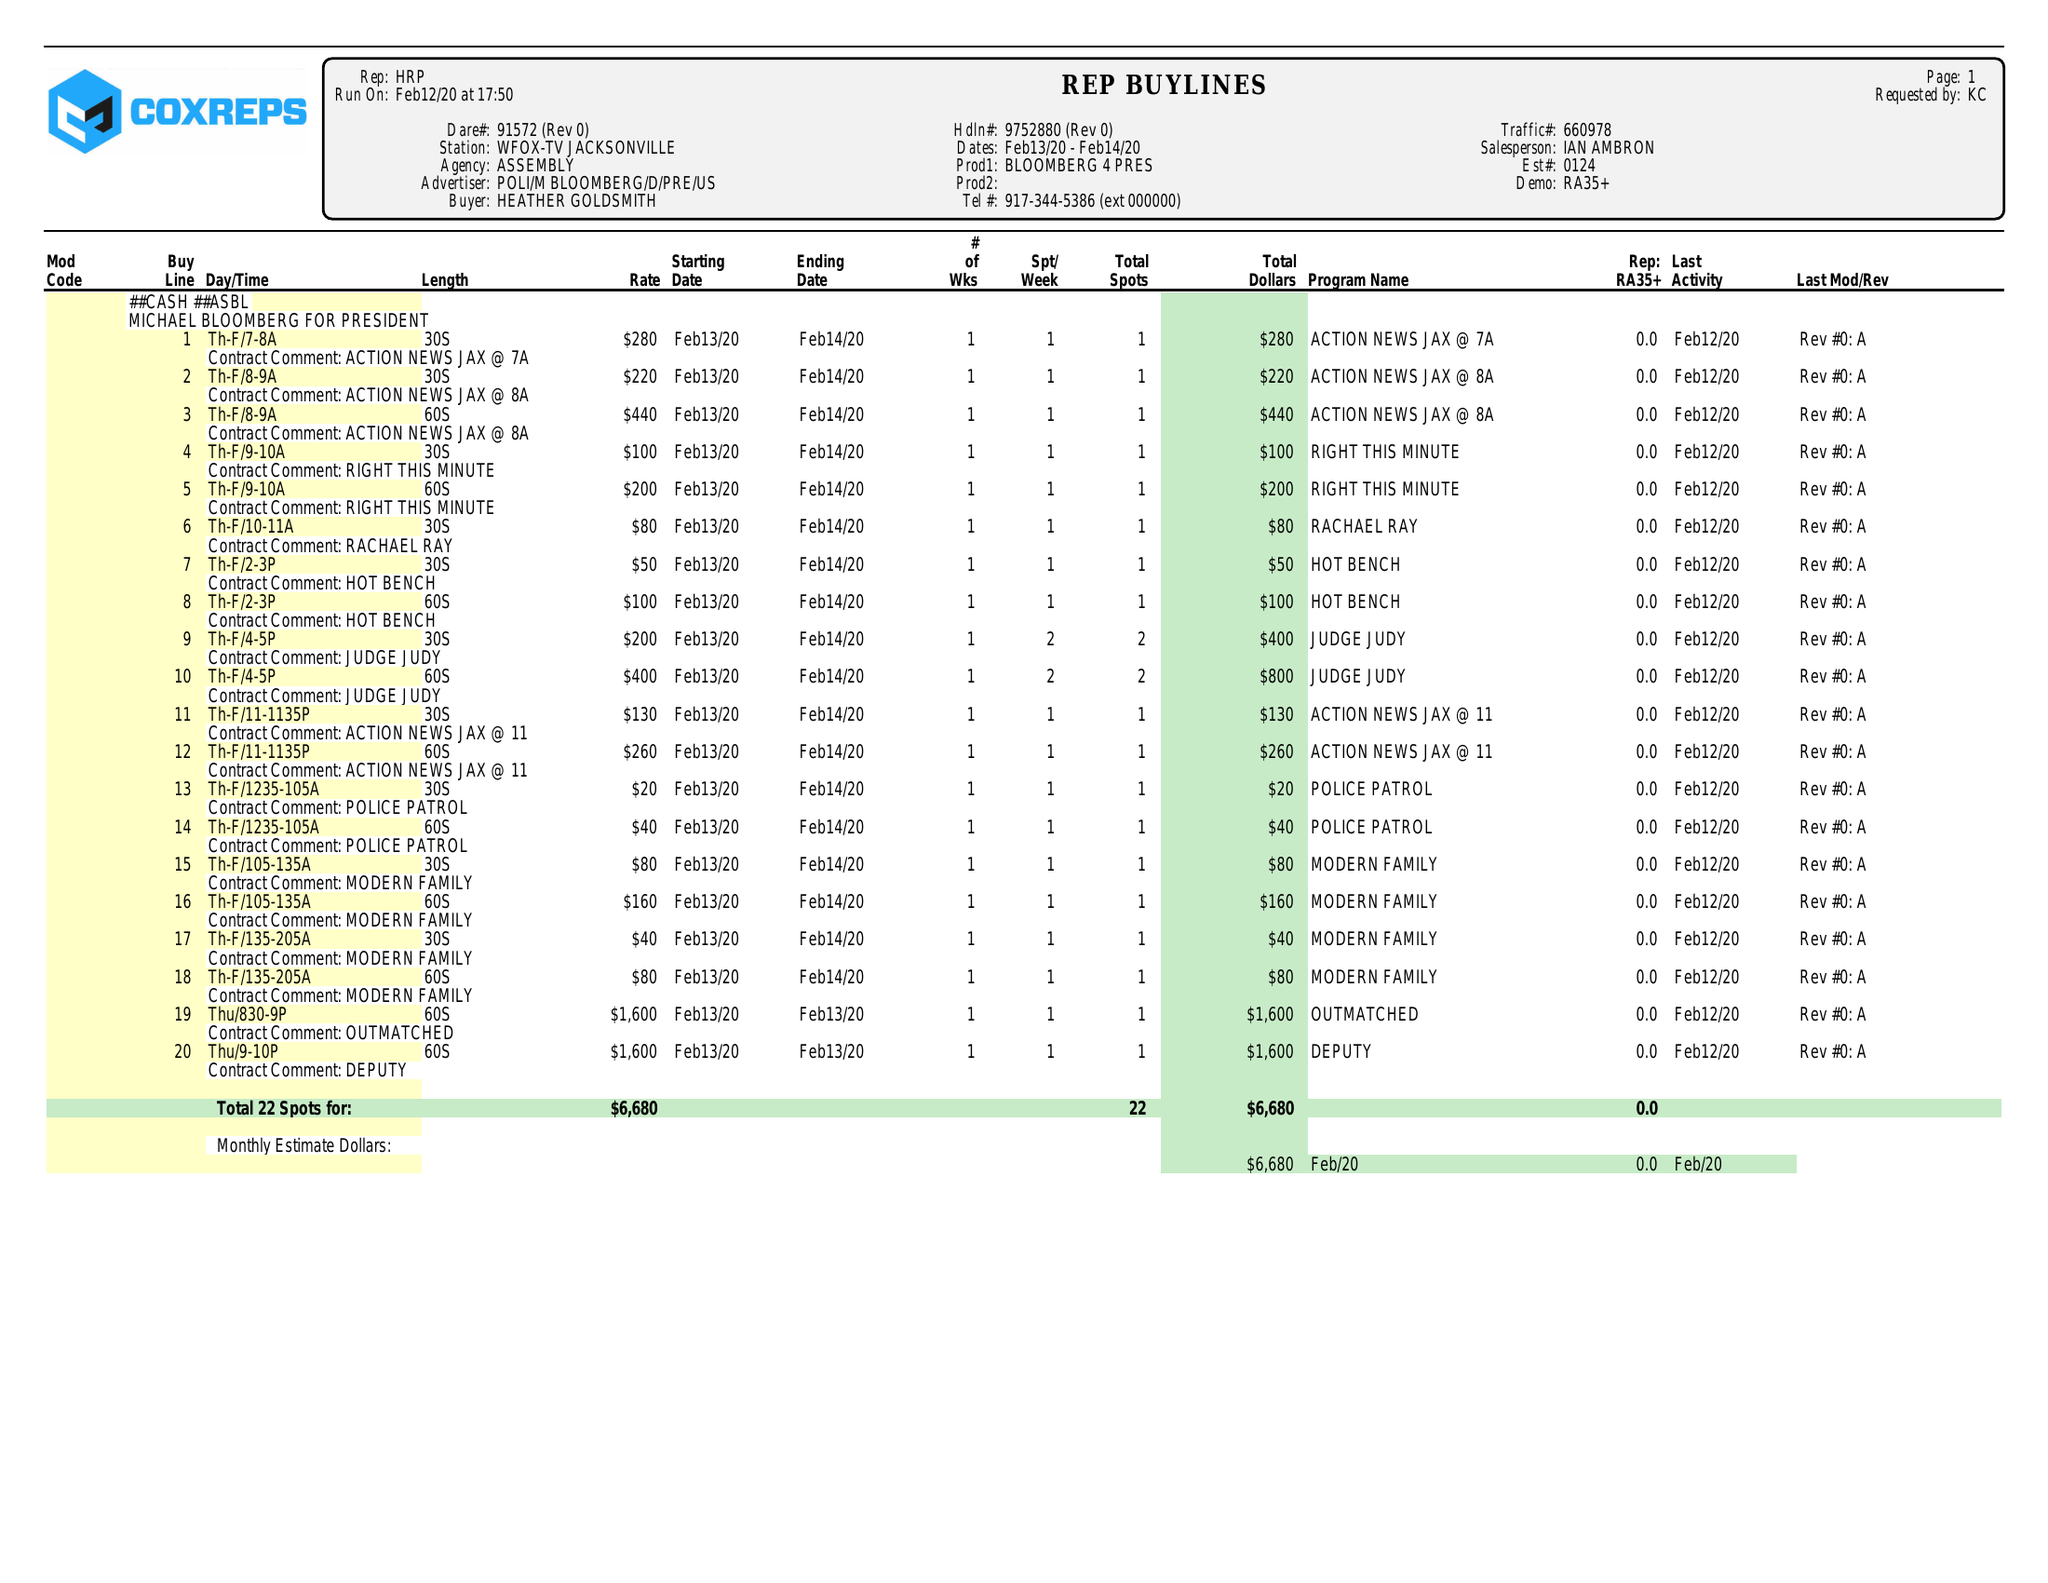What is the value for the flight_to?
Answer the question using a single word or phrase. 02/14/20 